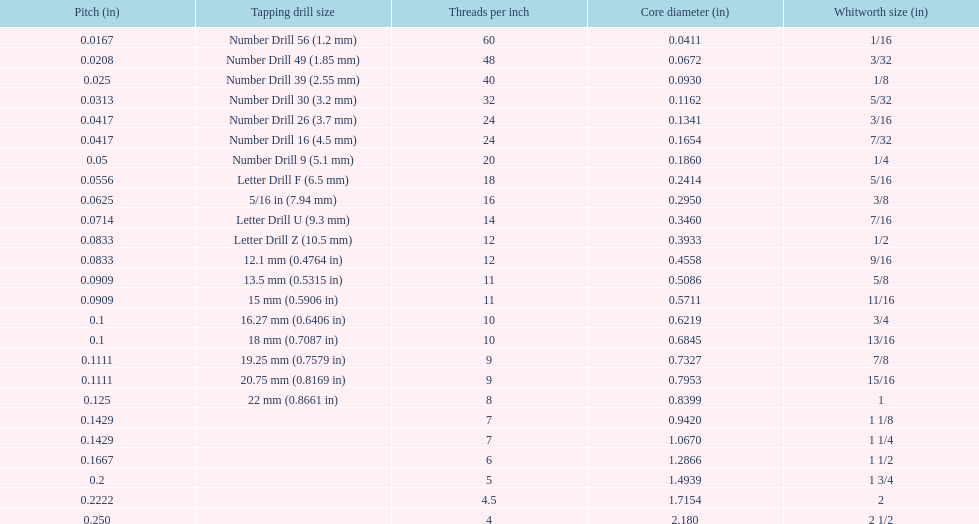What core diameter (in) comes after 0.0930? 0.1162. 